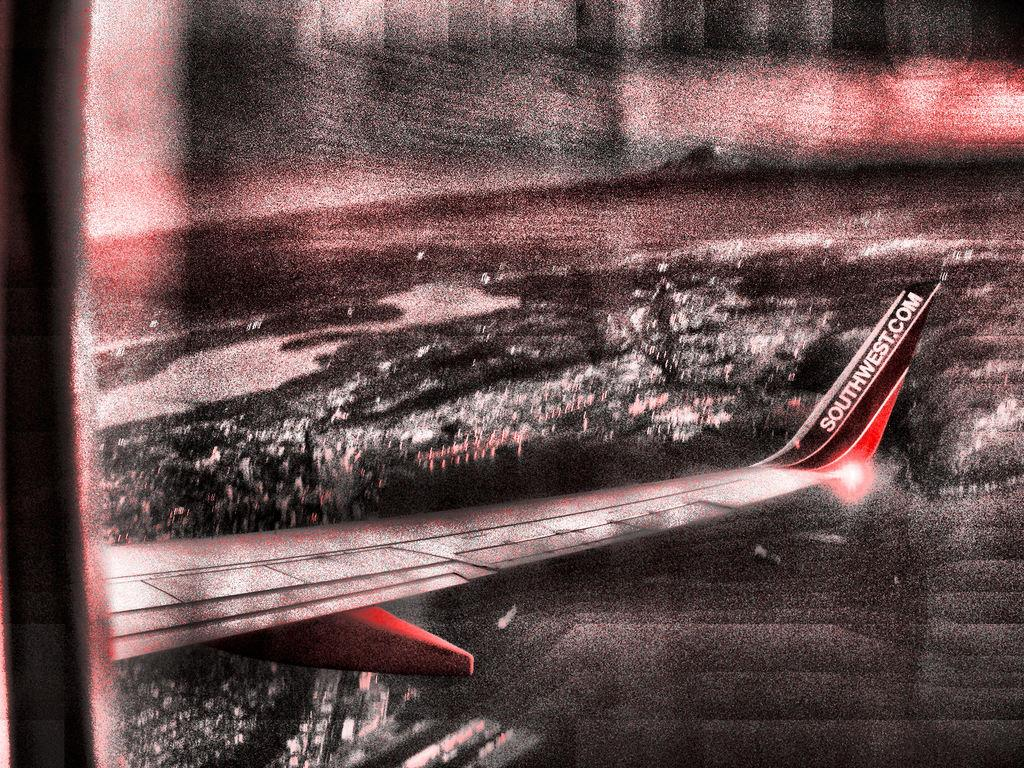<image>
Render a clear and concise summary of the photo. a Southwest plane wing from the window as it is landing 